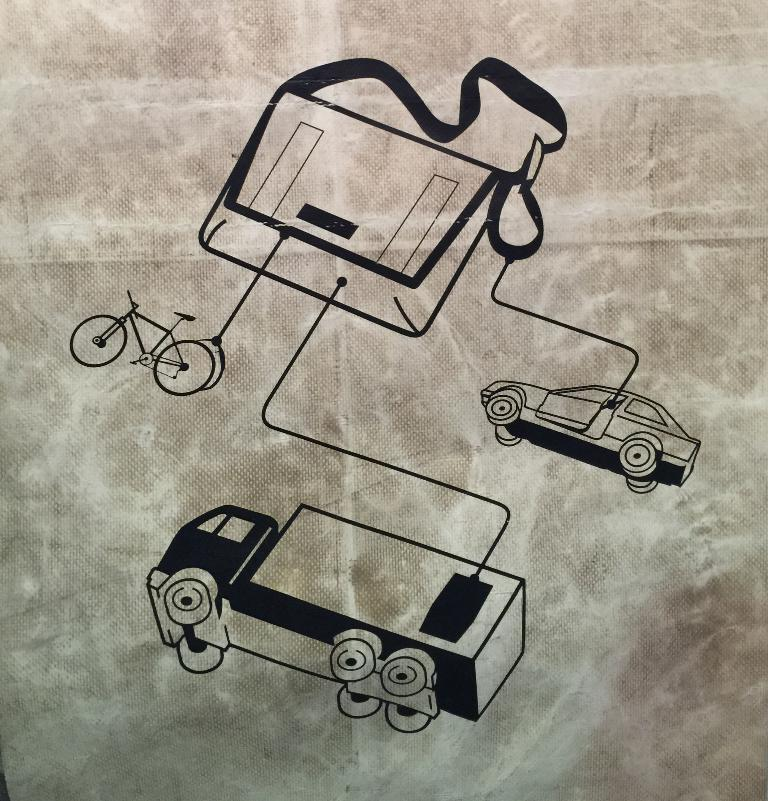What is depicted in the sketch in the image? There is a sketch of two vehicles in the image. What other object can be seen in the image besides the sketch? There is a bag in the image. What mode of transportation is present in the image? There is a bicycle in the image. What type of band is playing music in the image? There is no band present in the image; it features a sketch of two vehicles, a bag, and a bicycle. How many houses are visible in the image? There are no houses visible in the image. 